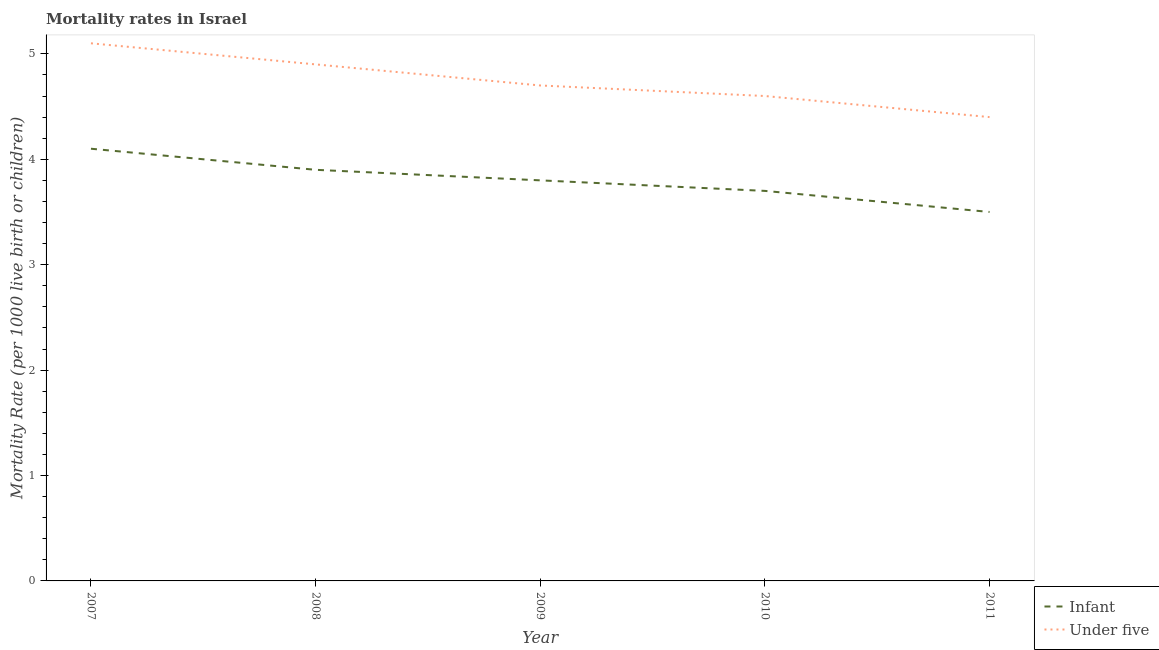Is the number of lines equal to the number of legend labels?
Your response must be concise. Yes. Across all years, what is the maximum infant mortality rate?
Provide a succinct answer. 4.1. Across all years, what is the minimum under-5 mortality rate?
Your response must be concise. 4.4. What is the total under-5 mortality rate in the graph?
Ensure brevity in your answer.  23.7. What is the difference between the infant mortality rate in 2007 and that in 2009?
Offer a very short reply. 0.3. What is the difference between the infant mortality rate in 2010 and the under-5 mortality rate in 2008?
Your answer should be compact. -1.2. What is the average infant mortality rate per year?
Give a very brief answer. 3.8. What is the ratio of the under-5 mortality rate in 2007 to that in 2009?
Keep it short and to the point. 1.09. Is the under-5 mortality rate in 2007 less than that in 2009?
Provide a succinct answer. No. Is the difference between the under-5 mortality rate in 2008 and 2009 greater than the difference between the infant mortality rate in 2008 and 2009?
Keep it short and to the point. Yes. What is the difference between the highest and the second highest under-5 mortality rate?
Offer a very short reply. 0.2. What is the difference between the highest and the lowest under-5 mortality rate?
Make the answer very short. 0.7. In how many years, is the under-5 mortality rate greater than the average under-5 mortality rate taken over all years?
Ensure brevity in your answer.  2. Is the sum of the infant mortality rate in 2007 and 2008 greater than the maximum under-5 mortality rate across all years?
Your answer should be compact. Yes. How many lines are there?
Offer a terse response. 2. How many years are there in the graph?
Give a very brief answer. 5. What is the difference between two consecutive major ticks on the Y-axis?
Offer a very short reply. 1. Are the values on the major ticks of Y-axis written in scientific E-notation?
Your answer should be compact. No. Where does the legend appear in the graph?
Keep it short and to the point. Bottom right. What is the title of the graph?
Give a very brief answer. Mortality rates in Israel. What is the label or title of the Y-axis?
Your answer should be compact. Mortality Rate (per 1000 live birth or children). What is the Mortality Rate (per 1000 live birth or children) of Infant in 2007?
Make the answer very short. 4.1. What is the Mortality Rate (per 1000 live birth or children) of Infant in 2008?
Make the answer very short. 3.9. What is the Mortality Rate (per 1000 live birth or children) of Infant in 2010?
Ensure brevity in your answer.  3.7. What is the Mortality Rate (per 1000 live birth or children) in Under five in 2010?
Provide a short and direct response. 4.6. What is the Mortality Rate (per 1000 live birth or children) of Infant in 2011?
Ensure brevity in your answer.  3.5. Across all years, what is the maximum Mortality Rate (per 1000 live birth or children) of Under five?
Provide a succinct answer. 5.1. Across all years, what is the minimum Mortality Rate (per 1000 live birth or children) of Infant?
Provide a succinct answer. 3.5. Across all years, what is the minimum Mortality Rate (per 1000 live birth or children) in Under five?
Offer a very short reply. 4.4. What is the total Mortality Rate (per 1000 live birth or children) of Infant in the graph?
Keep it short and to the point. 19. What is the total Mortality Rate (per 1000 live birth or children) of Under five in the graph?
Your answer should be compact. 23.7. What is the difference between the Mortality Rate (per 1000 live birth or children) in Infant in 2008 and that in 2009?
Your answer should be very brief. 0.1. What is the difference between the Mortality Rate (per 1000 live birth or children) in Infant in 2008 and that in 2010?
Your answer should be compact. 0.2. What is the difference between the Mortality Rate (per 1000 live birth or children) in Under five in 2008 and that in 2010?
Ensure brevity in your answer.  0.3. What is the difference between the Mortality Rate (per 1000 live birth or children) in Infant in 2008 and that in 2011?
Offer a very short reply. 0.4. What is the difference between the Mortality Rate (per 1000 live birth or children) of Under five in 2009 and that in 2010?
Your response must be concise. 0.1. What is the difference between the Mortality Rate (per 1000 live birth or children) in Under five in 2009 and that in 2011?
Give a very brief answer. 0.3. What is the difference between the Mortality Rate (per 1000 live birth or children) of Infant in 2010 and that in 2011?
Your answer should be very brief. 0.2. What is the difference between the Mortality Rate (per 1000 live birth or children) in Infant in 2007 and the Mortality Rate (per 1000 live birth or children) in Under five in 2008?
Your answer should be very brief. -0.8. What is the difference between the Mortality Rate (per 1000 live birth or children) in Infant in 2007 and the Mortality Rate (per 1000 live birth or children) in Under five in 2009?
Give a very brief answer. -0.6. What is the difference between the Mortality Rate (per 1000 live birth or children) of Infant in 2007 and the Mortality Rate (per 1000 live birth or children) of Under five in 2011?
Offer a terse response. -0.3. What is the difference between the Mortality Rate (per 1000 live birth or children) of Infant in 2008 and the Mortality Rate (per 1000 live birth or children) of Under five in 2010?
Provide a short and direct response. -0.7. What is the difference between the Mortality Rate (per 1000 live birth or children) in Infant in 2008 and the Mortality Rate (per 1000 live birth or children) in Under five in 2011?
Keep it short and to the point. -0.5. What is the difference between the Mortality Rate (per 1000 live birth or children) in Infant in 2009 and the Mortality Rate (per 1000 live birth or children) in Under five in 2011?
Make the answer very short. -0.6. What is the difference between the Mortality Rate (per 1000 live birth or children) in Infant in 2010 and the Mortality Rate (per 1000 live birth or children) in Under five in 2011?
Offer a very short reply. -0.7. What is the average Mortality Rate (per 1000 live birth or children) in Under five per year?
Ensure brevity in your answer.  4.74. In the year 2007, what is the difference between the Mortality Rate (per 1000 live birth or children) in Infant and Mortality Rate (per 1000 live birth or children) in Under five?
Offer a terse response. -1. What is the ratio of the Mortality Rate (per 1000 live birth or children) of Infant in 2007 to that in 2008?
Your answer should be very brief. 1.05. What is the ratio of the Mortality Rate (per 1000 live birth or children) in Under five in 2007 to that in 2008?
Your answer should be compact. 1.04. What is the ratio of the Mortality Rate (per 1000 live birth or children) in Infant in 2007 to that in 2009?
Offer a very short reply. 1.08. What is the ratio of the Mortality Rate (per 1000 live birth or children) of Under five in 2007 to that in 2009?
Provide a short and direct response. 1.09. What is the ratio of the Mortality Rate (per 1000 live birth or children) in Infant in 2007 to that in 2010?
Keep it short and to the point. 1.11. What is the ratio of the Mortality Rate (per 1000 live birth or children) in Under five in 2007 to that in 2010?
Offer a terse response. 1.11. What is the ratio of the Mortality Rate (per 1000 live birth or children) in Infant in 2007 to that in 2011?
Make the answer very short. 1.17. What is the ratio of the Mortality Rate (per 1000 live birth or children) of Under five in 2007 to that in 2011?
Your response must be concise. 1.16. What is the ratio of the Mortality Rate (per 1000 live birth or children) in Infant in 2008 to that in 2009?
Ensure brevity in your answer.  1.03. What is the ratio of the Mortality Rate (per 1000 live birth or children) in Under five in 2008 to that in 2009?
Offer a very short reply. 1.04. What is the ratio of the Mortality Rate (per 1000 live birth or children) of Infant in 2008 to that in 2010?
Give a very brief answer. 1.05. What is the ratio of the Mortality Rate (per 1000 live birth or children) in Under five in 2008 to that in 2010?
Your answer should be very brief. 1.07. What is the ratio of the Mortality Rate (per 1000 live birth or children) of Infant in 2008 to that in 2011?
Ensure brevity in your answer.  1.11. What is the ratio of the Mortality Rate (per 1000 live birth or children) of Under five in 2008 to that in 2011?
Make the answer very short. 1.11. What is the ratio of the Mortality Rate (per 1000 live birth or children) of Infant in 2009 to that in 2010?
Your response must be concise. 1.03. What is the ratio of the Mortality Rate (per 1000 live birth or children) of Under five in 2009 to that in 2010?
Give a very brief answer. 1.02. What is the ratio of the Mortality Rate (per 1000 live birth or children) of Infant in 2009 to that in 2011?
Offer a very short reply. 1.09. What is the ratio of the Mortality Rate (per 1000 live birth or children) of Under five in 2009 to that in 2011?
Provide a short and direct response. 1.07. What is the ratio of the Mortality Rate (per 1000 live birth or children) in Infant in 2010 to that in 2011?
Give a very brief answer. 1.06. What is the ratio of the Mortality Rate (per 1000 live birth or children) of Under five in 2010 to that in 2011?
Offer a very short reply. 1.05. What is the difference between the highest and the second highest Mortality Rate (per 1000 live birth or children) in Infant?
Offer a terse response. 0.2. What is the difference between the highest and the second highest Mortality Rate (per 1000 live birth or children) of Under five?
Keep it short and to the point. 0.2. What is the difference between the highest and the lowest Mortality Rate (per 1000 live birth or children) of Under five?
Provide a succinct answer. 0.7. 